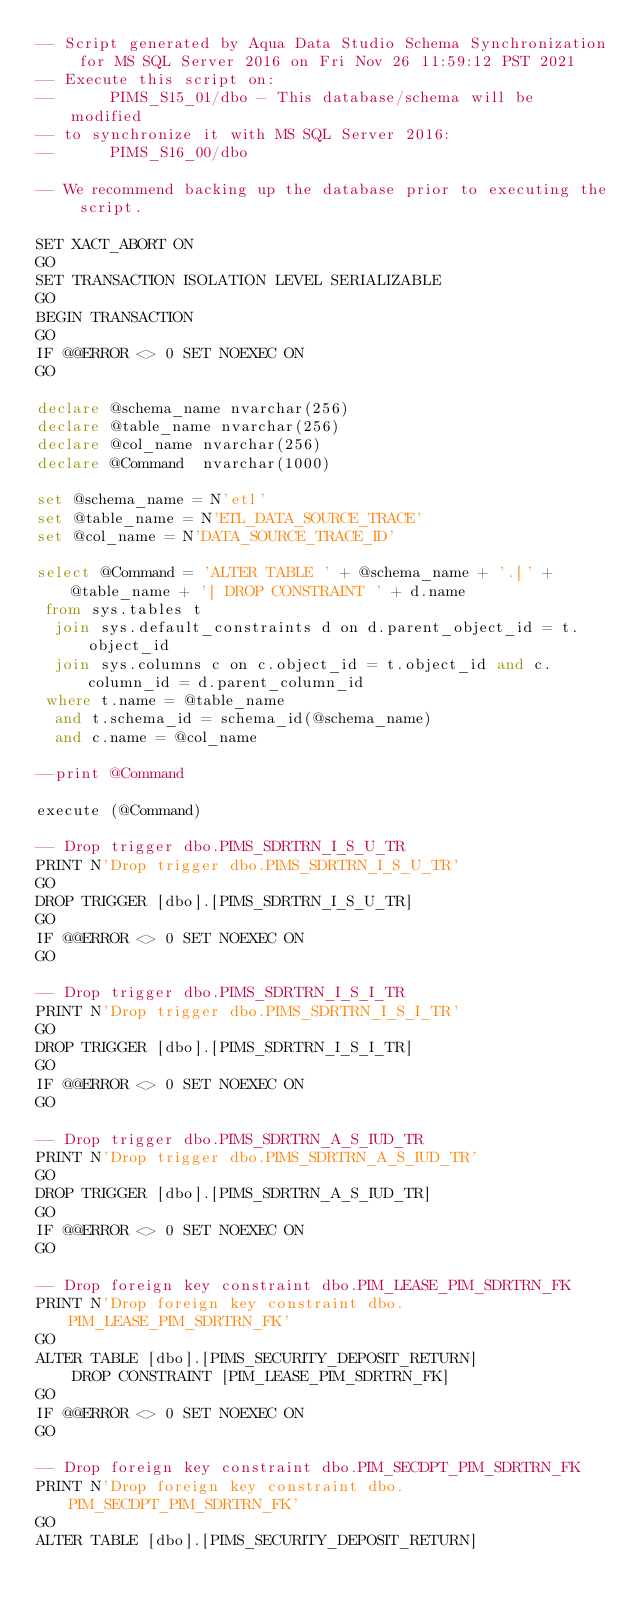Convert code to text. <code><loc_0><loc_0><loc_500><loc_500><_SQL_>-- Script generated by Aqua Data Studio Schema Synchronization for MS SQL Server 2016 on Fri Nov 26 11:59:12 PST 2021
-- Execute this script on:
-- 		PIMS_S15_01/dbo - This database/schema will be modified
-- to synchronize it with MS SQL Server 2016:
-- 		PIMS_S16_00/dbo

-- We recommend backing up the database prior to executing the script.

SET XACT_ABORT ON
GO
SET TRANSACTION ISOLATION LEVEL SERIALIZABLE
GO
BEGIN TRANSACTION
GO
IF @@ERROR <> 0 SET NOEXEC ON
GO

declare @schema_name nvarchar(256)
declare @table_name nvarchar(256)
declare @col_name nvarchar(256)
declare @Command  nvarchar(1000)

set @schema_name = N'etl'
set @table_name = N'ETL_DATA_SOURCE_TRACE'
set @col_name = N'DATA_SOURCE_TRACE_ID'

select @Command = 'ALTER TABLE ' + @schema_name + '.[' + @table_name + '] DROP CONSTRAINT ' + d.name
 from sys.tables t
  join sys.default_constraints d on d.parent_object_id = t.object_id
  join sys.columns c on c.object_id = t.object_id and c.column_id = d.parent_column_id
 where t.name = @table_name
  and t.schema_id = schema_id(@schema_name)
  and c.name = @col_name

--print @Command

execute (@Command)

-- Drop trigger dbo.PIMS_SDRTRN_I_S_U_TR
PRINT N'Drop trigger dbo.PIMS_SDRTRN_I_S_U_TR'
GO
DROP TRIGGER [dbo].[PIMS_SDRTRN_I_S_U_TR]
GO
IF @@ERROR <> 0 SET NOEXEC ON
GO

-- Drop trigger dbo.PIMS_SDRTRN_I_S_I_TR
PRINT N'Drop trigger dbo.PIMS_SDRTRN_I_S_I_TR'
GO
DROP TRIGGER [dbo].[PIMS_SDRTRN_I_S_I_TR]
GO
IF @@ERROR <> 0 SET NOEXEC ON
GO

-- Drop trigger dbo.PIMS_SDRTRN_A_S_IUD_TR
PRINT N'Drop trigger dbo.PIMS_SDRTRN_A_S_IUD_TR'
GO
DROP TRIGGER [dbo].[PIMS_SDRTRN_A_S_IUD_TR]
GO
IF @@ERROR <> 0 SET NOEXEC ON
GO

-- Drop foreign key constraint dbo.PIM_LEASE_PIM_SDRTRN_FK
PRINT N'Drop foreign key constraint dbo.PIM_LEASE_PIM_SDRTRN_FK'
GO
ALTER TABLE [dbo].[PIMS_SECURITY_DEPOSIT_RETURN]
	DROP CONSTRAINT [PIM_LEASE_PIM_SDRTRN_FK]
GO
IF @@ERROR <> 0 SET NOEXEC ON
GO

-- Drop foreign key constraint dbo.PIM_SECDPT_PIM_SDRTRN_FK
PRINT N'Drop foreign key constraint dbo.PIM_SECDPT_PIM_SDRTRN_FK'
GO
ALTER TABLE [dbo].[PIMS_SECURITY_DEPOSIT_RETURN]</code> 